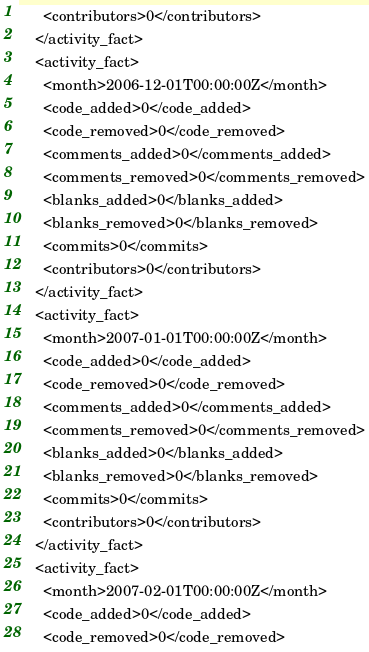<code> <loc_0><loc_0><loc_500><loc_500><_XML_>      <contributors>0</contributors>
    </activity_fact>
    <activity_fact>
      <month>2006-12-01T00:00:00Z</month>
      <code_added>0</code_added>
      <code_removed>0</code_removed>
      <comments_added>0</comments_added>
      <comments_removed>0</comments_removed>
      <blanks_added>0</blanks_added>
      <blanks_removed>0</blanks_removed>
      <commits>0</commits>
      <contributors>0</contributors>
    </activity_fact>
    <activity_fact>
      <month>2007-01-01T00:00:00Z</month>
      <code_added>0</code_added>
      <code_removed>0</code_removed>
      <comments_added>0</comments_added>
      <comments_removed>0</comments_removed>
      <blanks_added>0</blanks_added>
      <blanks_removed>0</blanks_removed>
      <commits>0</commits>
      <contributors>0</contributors>
    </activity_fact>
    <activity_fact>
      <month>2007-02-01T00:00:00Z</month>
      <code_added>0</code_added>
      <code_removed>0</code_removed></code> 